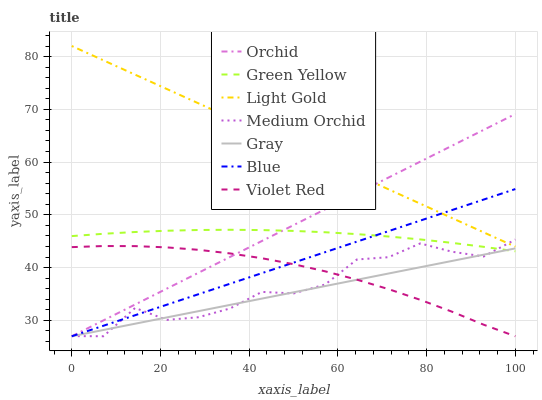Does Violet Red have the minimum area under the curve?
Answer yes or no. No. Does Violet Red have the maximum area under the curve?
Answer yes or no. No. Is Violet Red the smoothest?
Answer yes or no. No. Is Violet Red the roughest?
Answer yes or no. No. Does Green Yellow have the lowest value?
Answer yes or no. No. Does Violet Red have the highest value?
Answer yes or no. No. Is Gray less than Light Gold?
Answer yes or no. Yes. Is Green Yellow greater than Violet Red?
Answer yes or no. Yes. Does Gray intersect Light Gold?
Answer yes or no. No. 